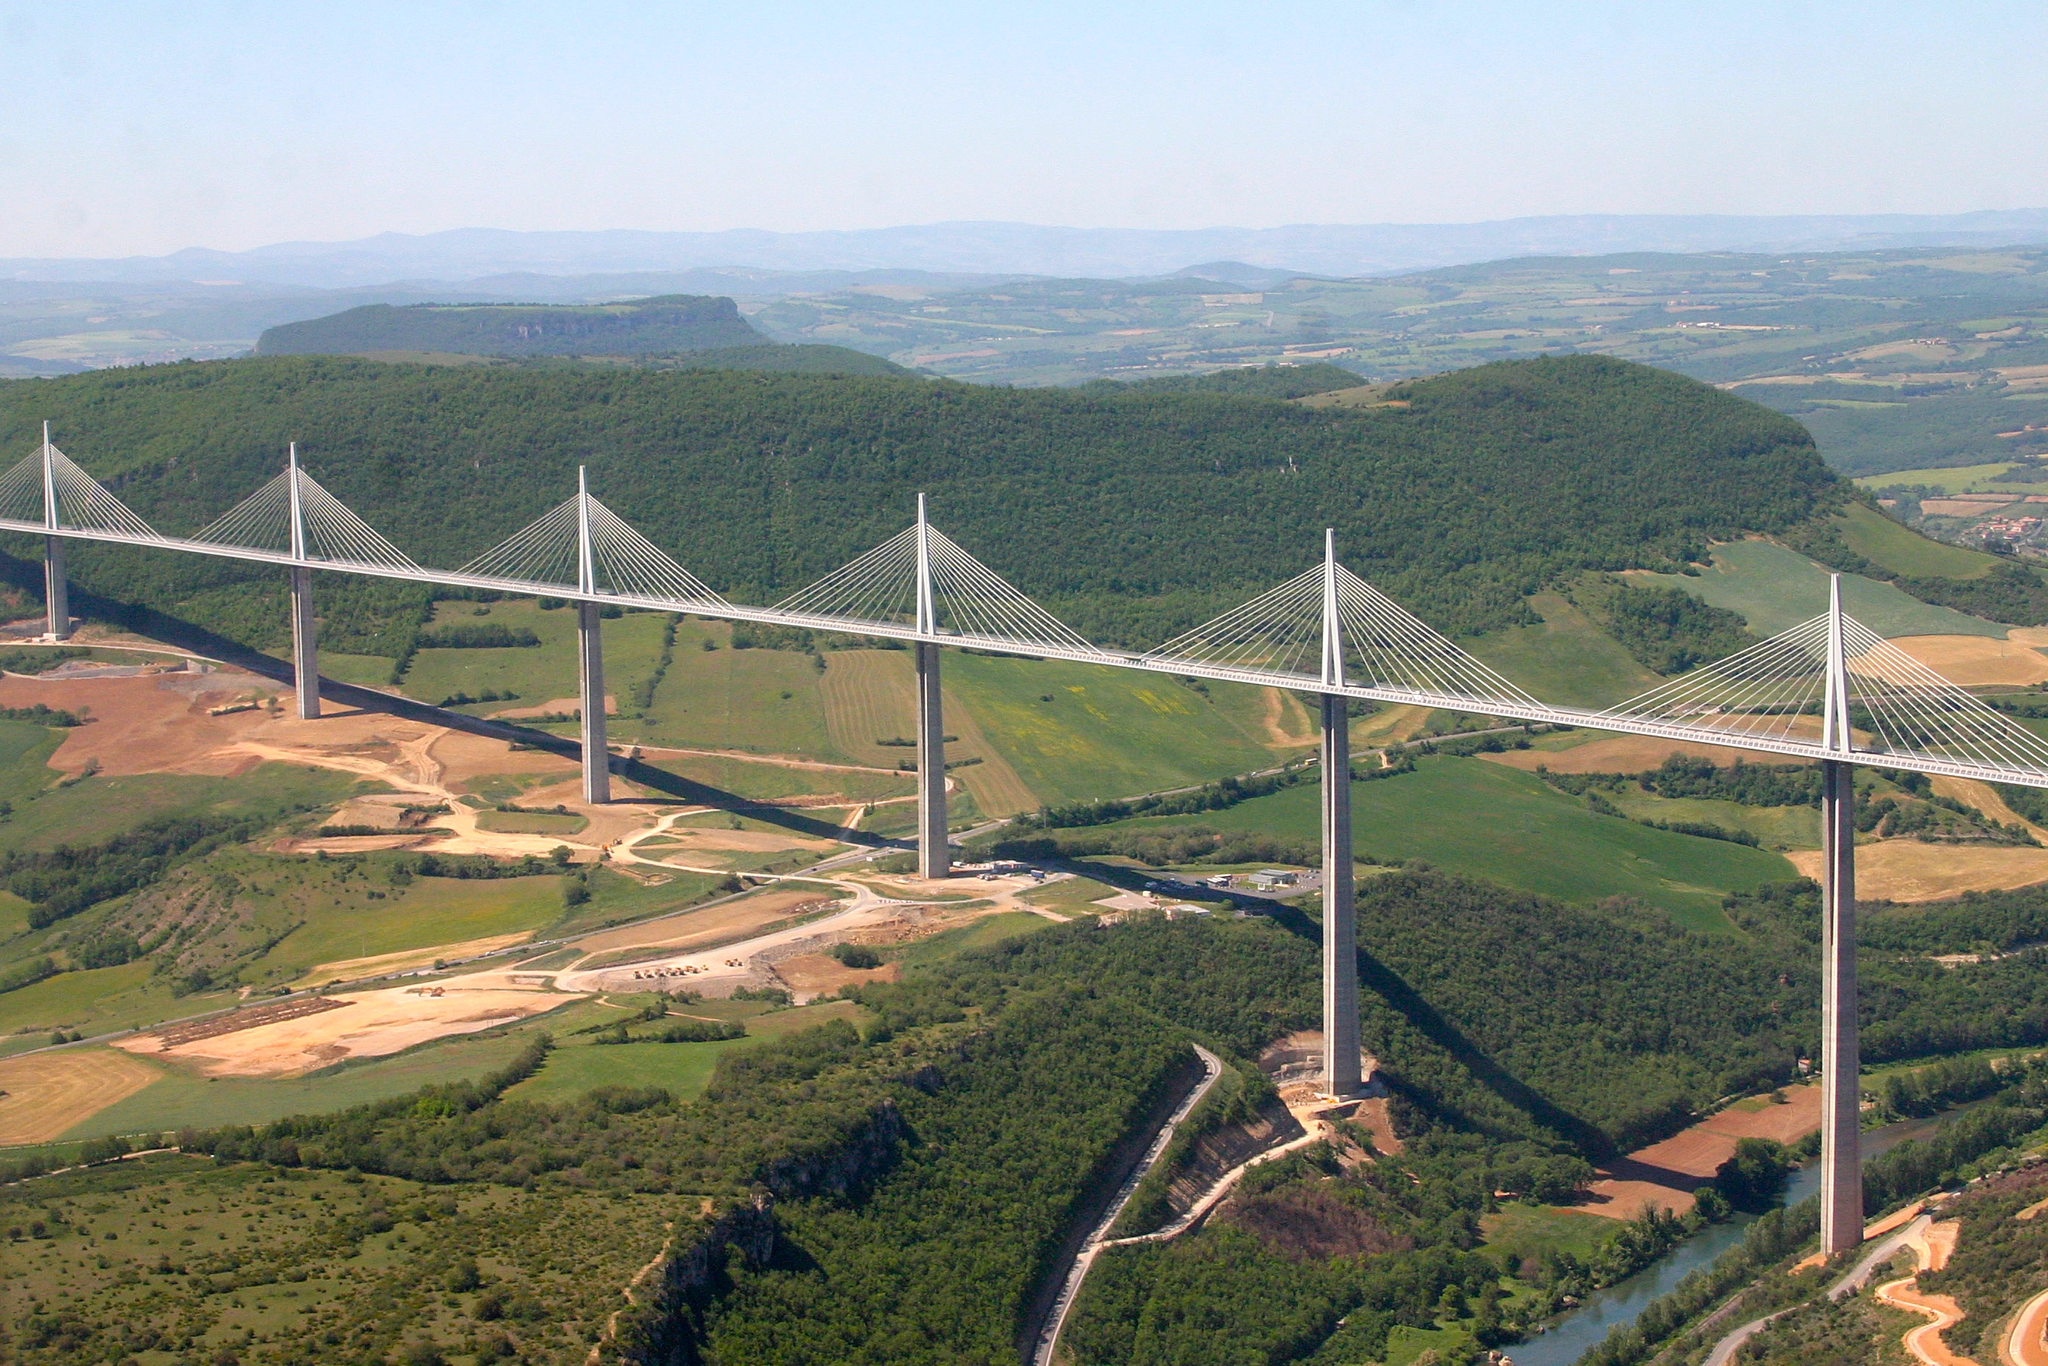What challenges might engineers have faced when constructing the Millau Viaduct? Constructing the Millau Viaduct posed several significant engineering challenges. The height of the bridge, at 343 meters above the valley floor, required innovative solutions to withstand wind speeds and weather conditions. Engineers had to ensure structural stability while minimizing environmental impact on the surrounding valley. Furthermore, the design included extensive wind tunnel testing and geological studies to secure the bridge against natural forces, illustrating the complex coordination between various engineering disciplines needed to complete this ambitious project. 